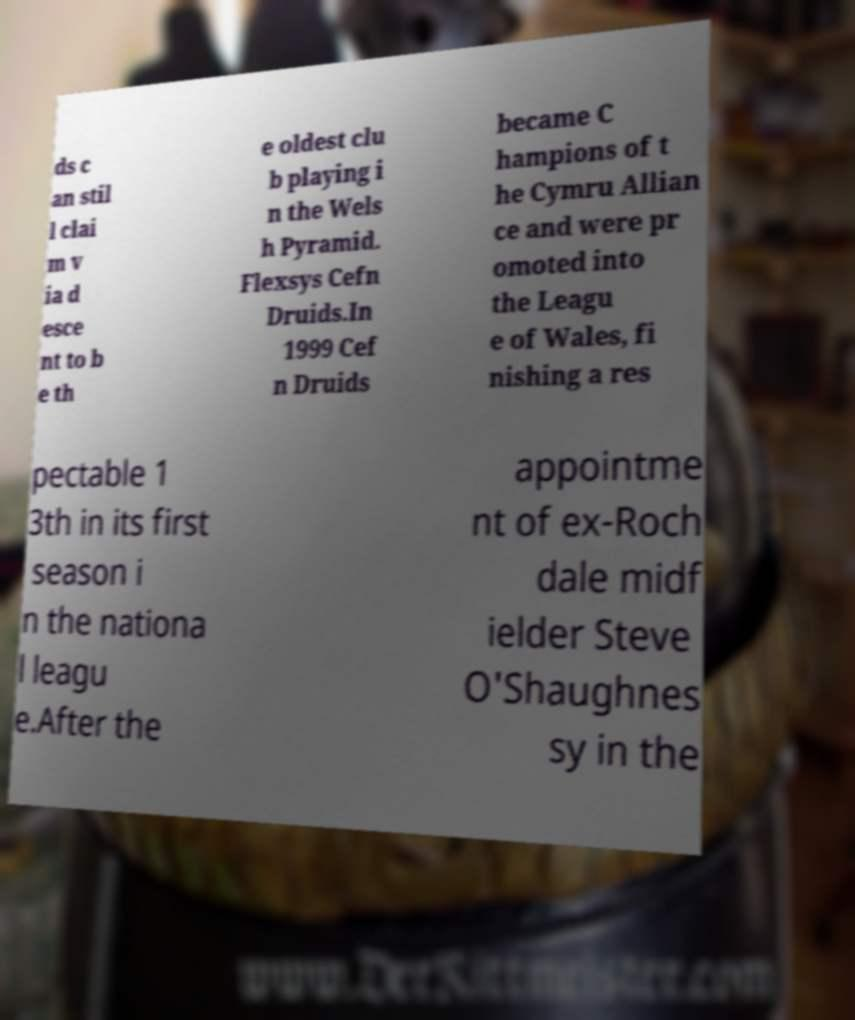Could you extract and type out the text from this image? ds c an stil l clai m v ia d esce nt to b e th e oldest clu b playing i n the Wels h Pyramid. Flexsys Cefn Druids.In 1999 Cef n Druids became C hampions of t he Cymru Allian ce and were pr omoted into the Leagu e of Wales, fi nishing a res pectable 1 3th in its first season i n the nationa l leagu e.After the appointme nt of ex-Roch dale midf ielder Steve O'Shaughnes sy in the 